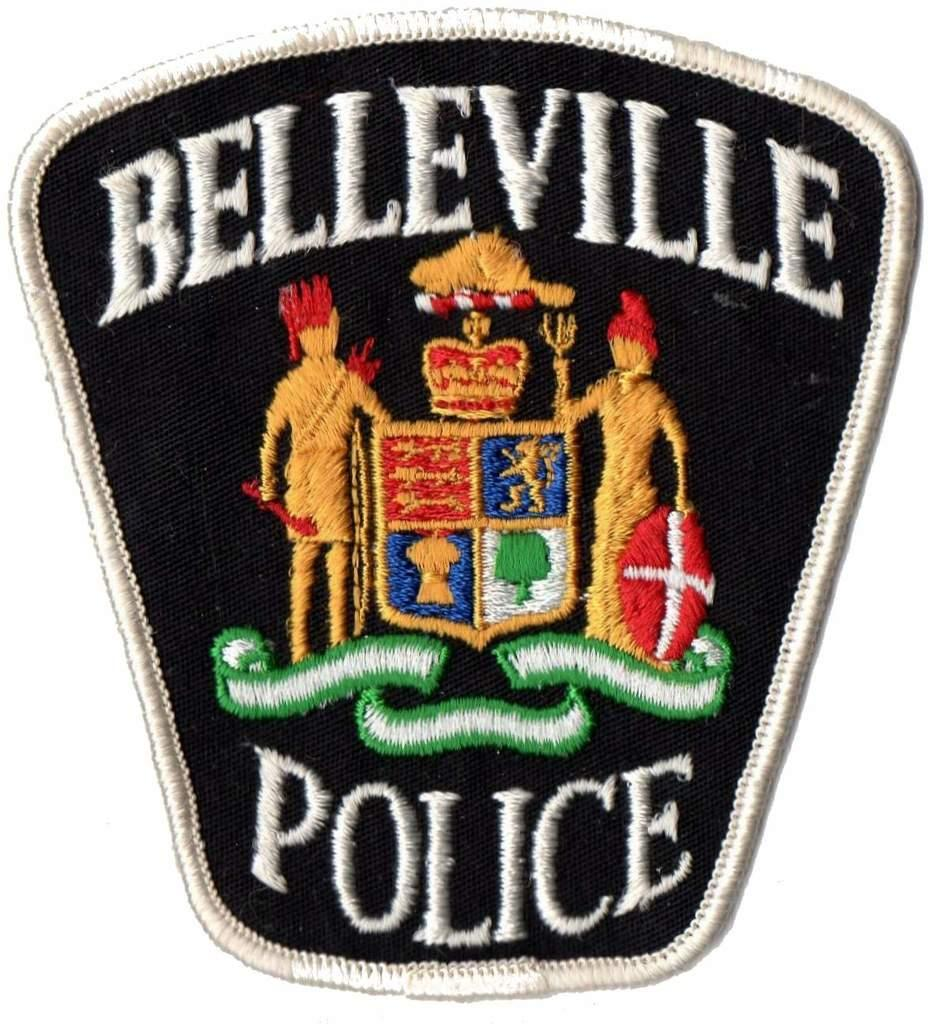What is the main subject of the image? The main subject of the image is an emblem. What type of honey is being used to decorate the cake in the image? There is no cake or honey present in the image; it only features an emblem. 